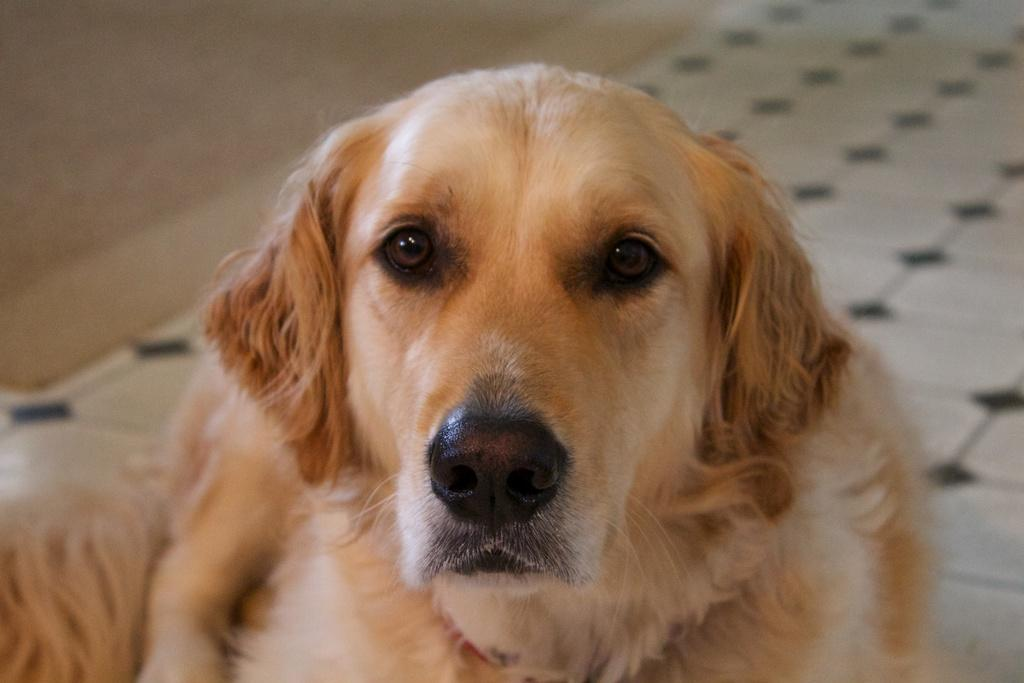What animal can be seen in the image? There is a dog in the image. What is the dog doing in the image? The dog is sitting on the floor. What type of flooring is visible in the image? The floor has tiles. What is located behind the dog in the image? There is a wall behind the dog. What type of hair can be seen on the fowl in the image? There is no fowl or hair present in the image; it features a dog sitting on a tiled floor with a wall behind it. 